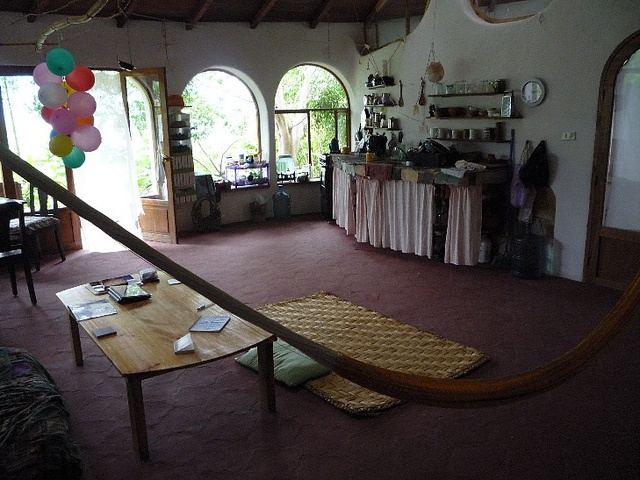Describe the objects in this image and their specific colors. I can see dining table in black, gray, and darkgray tones, couch in black, gray, and purple tones, chair in black, gray, white, and darkgray tones, chair in black, gray, lightgray, and darkgray tones, and handbag in black and gray tones in this image. 